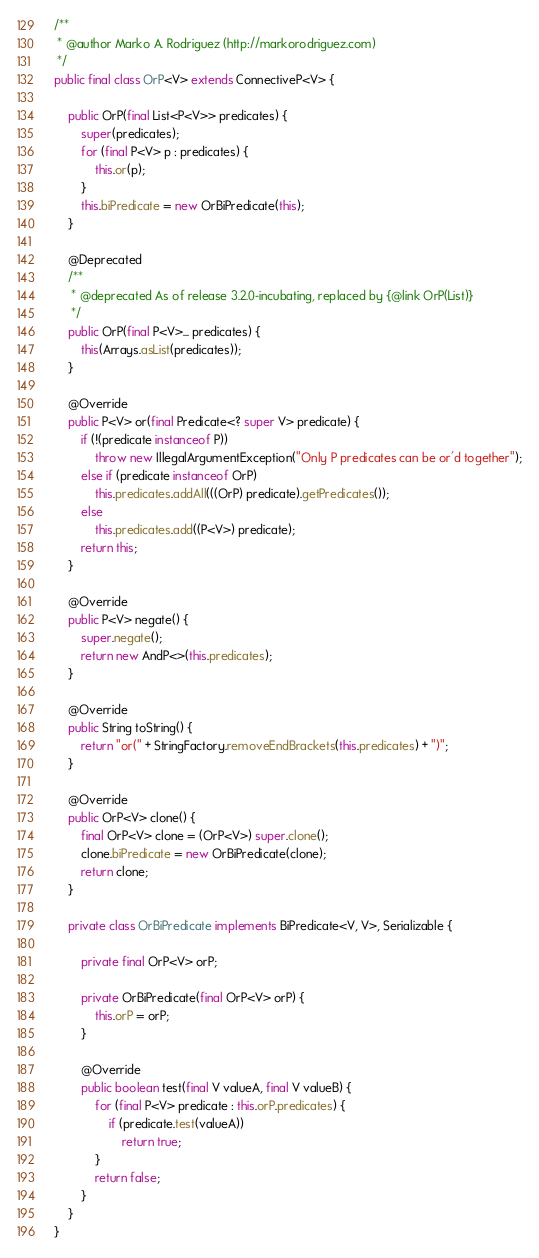Convert code to text. <code><loc_0><loc_0><loc_500><loc_500><_Java_>
/**
 * @author Marko A. Rodriguez (http://markorodriguez.com)
 */
public final class OrP<V> extends ConnectiveP<V> {

    public OrP(final List<P<V>> predicates) {
        super(predicates);
        for (final P<V> p : predicates) {
            this.or(p);
        }
        this.biPredicate = new OrBiPredicate(this);
    }

    @Deprecated
    /**
     * @deprecated As of release 3.2.0-incubating, replaced by {@link OrP(List)}
     */
    public OrP(final P<V>... predicates) {
        this(Arrays.asList(predicates));
    }

    @Override
    public P<V> or(final Predicate<? super V> predicate) {
        if (!(predicate instanceof P))
            throw new IllegalArgumentException("Only P predicates can be or'd together");
        else if (predicate instanceof OrP)
            this.predicates.addAll(((OrP) predicate).getPredicates());
        else
            this.predicates.add((P<V>) predicate);
        return this;
    }

    @Override
    public P<V> negate() {
        super.negate();
        return new AndP<>(this.predicates);
    }

    @Override
    public String toString() {
        return "or(" + StringFactory.removeEndBrackets(this.predicates) + ")";
    }

    @Override
    public OrP<V> clone() {
        final OrP<V> clone = (OrP<V>) super.clone();
        clone.biPredicate = new OrBiPredicate(clone);
        return clone;
    }

    private class OrBiPredicate implements BiPredicate<V, V>, Serializable {

        private final OrP<V> orP;

        private OrBiPredicate(final OrP<V> orP) {
            this.orP = orP;
        }

        @Override
        public boolean test(final V valueA, final V valueB) {
            for (final P<V> predicate : this.orP.predicates) {
                if (predicate.test(valueA))
                    return true;
            }
            return false;
        }
    }
}</code> 